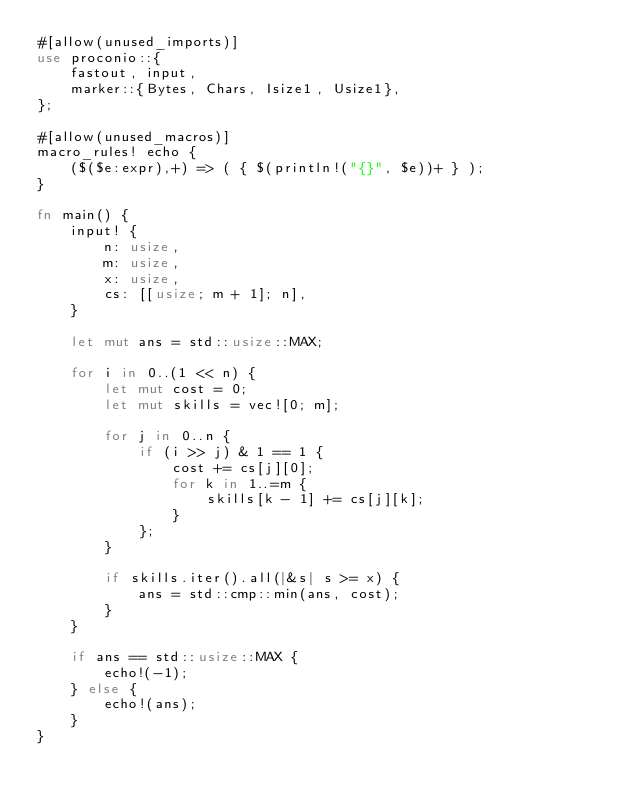<code> <loc_0><loc_0><loc_500><loc_500><_Rust_>#[allow(unused_imports)]
use proconio::{
    fastout, input,
    marker::{Bytes, Chars, Isize1, Usize1},
};

#[allow(unused_macros)]
macro_rules! echo {
    ($($e:expr),+) => ( { $(println!("{}", $e))+ } );
}

fn main() {
    input! {
        n: usize,
        m: usize,
        x: usize,
        cs: [[usize; m + 1]; n],
    }

    let mut ans = std::usize::MAX;

    for i in 0..(1 << n) {
        let mut cost = 0;
        let mut skills = vec![0; m];

        for j in 0..n {
            if (i >> j) & 1 == 1 {
                cost += cs[j][0];
                for k in 1..=m {
                    skills[k - 1] += cs[j][k];
                }
            };
        }

        if skills.iter().all(|&s| s >= x) {
            ans = std::cmp::min(ans, cost);
        }
    }

    if ans == std::usize::MAX {
        echo!(-1);
    } else {
        echo!(ans);
    }
}
</code> 